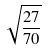<formula> <loc_0><loc_0><loc_500><loc_500>\sqrt { \frac { 2 7 } { 7 0 } }</formula> 